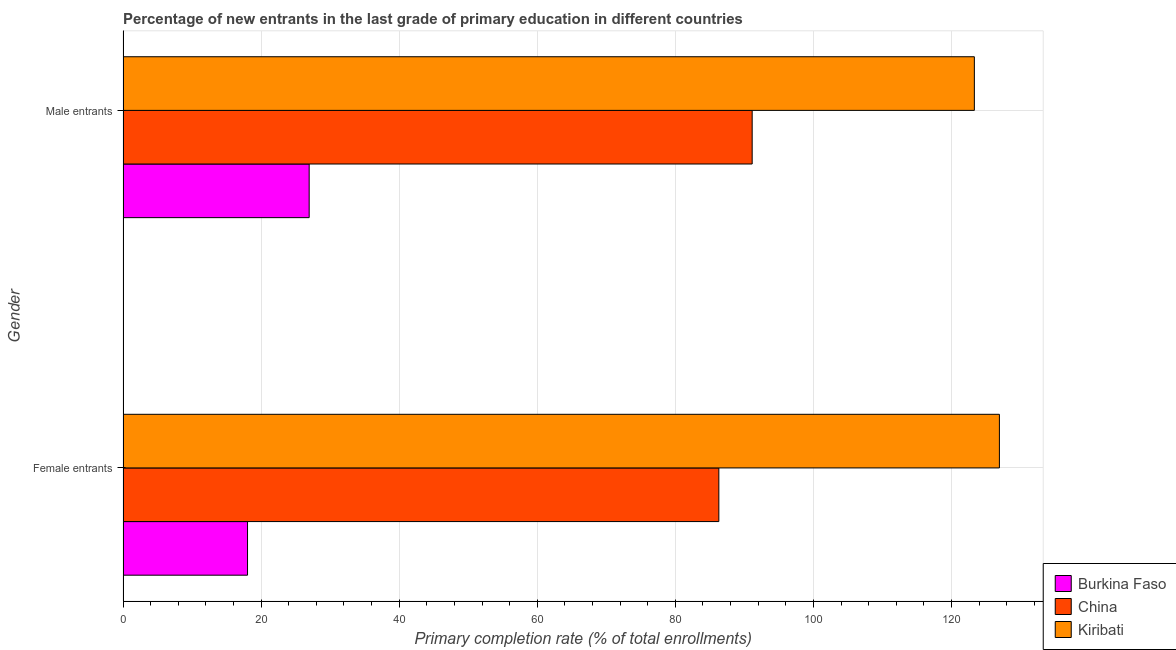Are the number of bars on each tick of the Y-axis equal?
Provide a succinct answer. Yes. How many bars are there on the 1st tick from the top?
Provide a succinct answer. 3. What is the label of the 2nd group of bars from the top?
Provide a short and direct response. Female entrants. What is the primary completion rate of male entrants in Burkina Faso?
Offer a terse response. 26.97. Across all countries, what is the maximum primary completion rate of female entrants?
Offer a terse response. 126.94. Across all countries, what is the minimum primary completion rate of female entrants?
Keep it short and to the point. 18.04. In which country was the primary completion rate of female entrants maximum?
Your response must be concise. Kiribati. In which country was the primary completion rate of female entrants minimum?
Provide a short and direct response. Burkina Faso. What is the total primary completion rate of male entrants in the graph?
Your answer should be very brief. 241.41. What is the difference between the primary completion rate of male entrants in Kiribati and that in Burkina Faso?
Give a very brief answer. 96.35. What is the difference between the primary completion rate of male entrants in Burkina Faso and the primary completion rate of female entrants in Kiribati?
Keep it short and to the point. -99.97. What is the average primary completion rate of male entrants per country?
Your answer should be compact. 80.47. What is the difference between the primary completion rate of female entrants and primary completion rate of male entrants in Kiribati?
Provide a succinct answer. 3.63. What is the ratio of the primary completion rate of male entrants in China to that in Kiribati?
Your response must be concise. 0.74. Is the primary completion rate of female entrants in China less than that in Kiribati?
Provide a short and direct response. Yes. In how many countries, is the primary completion rate of female entrants greater than the average primary completion rate of female entrants taken over all countries?
Your answer should be compact. 2. What does the 2nd bar from the top in Male entrants represents?
Give a very brief answer. China. What does the 1st bar from the bottom in Female entrants represents?
Make the answer very short. Burkina Faso. Are the values on the major ticks of X-axis written in scientific E-notation?
Offer a very short reply. No. Where does the legend appear in the graph?
Provide a short and direct response. Bottom right. How are the legend labels stacked?
Your answer should be very brief. Vertical. What is the title of the graph?
Your response must be concise. Percentage of new entrants in the last grade of primary education in different countries. Does "Seychelles" appear as one of the legend labels in the graph?
Provide a short and direct response. No. What is the label or title of the X-axis?
Provide a short and direct response. Primary completion rate (% of total enrollments). What is the label or title of the Y-axis?
Ensure brevity in your answer.  Gender. What is the Primary completion rate (% of total enrollments) in Burkina Faso in Female entrants?
Your answer should be compact. 18.04. What is the Primary completion rate (% of total enrollments) in China in Female entrants?
Offer a terse response. 86.3. What is the Primary completion rate (% of total enrollments) in Kiribati in Female entrants?
Provide a short and direct response. 126.94. What is the Primary completion rate (% of total enrollments) of Burkina Faso in Male entrants?
Your answer should be compact. 26.97. What is the Primary completion rate (% of total enrollments) of China in Male entrants?
Provide a succinct answer. 91.13. What is the Primary completion rate (% of total enrollments) of Kiribati in Male entrants?
Give a very brief answer. 123.31. Across all Gender, what is the maximum Primary completion rate (% of total enrollments) of Burkina Faso?
Your answer should be very brief. 26.97. Across all Gender, what is the maximum Primary completion rate (% of total enrollments) of China?
Your answer should be very brief. 91.13. Across all Gender, what is the maximum Primary completion rate (% of total enrollments) in Kiribati?
Offer a terse response. 126.94. Across all Gender, what is the minimum Primary completion rate (% of total enrollments) in Burkina Faso?
Provide a short and direct response. 18.04. Across all Gender, what is the minimum Primary completion rate (% of total enrollments) of China?
Ensure brevity in your answer.  86.3. Across all Gender, what is the minimum Primary completion rate (% of total enrollments) in Kiribati?
Make the answer very short. 123.31. What is the total Primary completion rate (% of total enrollments) in Burkina Faso in the graph?
Provide a short and direct response. 45. What is the total Primary completion rate (% of total enrollments) of China in the graph?
Give a very brief answer. 177.43. What is the total Primary completion rate (% of total enrollments) in Kiribati in the graph?
Offer a terse response. 250.25. What is the difference between the Primary completion rate (% of total enrollments) of Burkina Faso in Female entrants and that in Male entrants?
Provide a short and direct response. -8.93. What is the difference between the Primary completion rate (% of total enrollments) in China in Female entrants and that in Male entrants?
Your answer should be very brief. -4.83. What is the difference between the Primary completion rate (% of total enrollments) of Kiribati in Female entrants and that in Male entrants?
Ensure brevity in your answer.  3.63. What is the difference between the Primary completion rate (% of total enrollments) of Burkina Faso in Female entrants and the Primary completion rate (% of total enrollments) of China in Male entrants?
Offer a very short reply. -73.09. What is the difference between the Primary completion rate (% of total enrollments) in Burkina Faso in Female entrants and the Primary completion rate (% of total enrollments) in Kiribati in Male entrants?
Make the answer very short. -105.27. What is the difference between the Primary completion rate (% of total enrollments) of China in Female entrants and the Primary completion rate (% of total enrollments) of Kiribati in Male entrants?
Provide a short and direct response. -37.01. What is the average Primary completion rate (% of total enrollments) in Burkina Faso per Gender?
Offer a very short reply. 22.5. What is the average Primary completion rate (% of total enrollments) of China per Gender?
Your answer should be compact. 88.72. What is the average Primary completion rate (% of total enrollments) of Kiribati per Gender?
Offer a terse response. 125.13. What is the difference between the Primary completion rate (% of total enrollments) of Burkina Faso and Primary completion rate (% of total enrollments) of China in Female entrants?
Ensure brevity in your answer.  -68.27. What is the difference between the Primary completion rate (% of total enrollments) of Burkina Faso and Primary completion rate (% of total enrollments) of Kiribati in Female entrants?
Keep it short and to the point. -108.9. What is the difference between the Primary completion rate (% of total enrollments) in China and Primary completion rate (% of total enrollments) in Kiribati in Female entrants?
Your answer should be compact. -40.64. What is the difference between the Primary completion rate (% of total enrollments) in Burkina Faso and Primary completion rate (% of total enrollments) in China in Male entrants?
Your response must be concise. -64.17. What is the difference between the Primary completion rate (% of total enrollments) in Burkina Faso and Primary completion rate (% of total enrollments) in Kiribati in Male entrants?
Provide a succinct answer. -96.35. What is the difference between the Primary completion rate (% of total enrollments) of China and Primary completion rate (% of total enrollments) of Kiribati in Male entrants?
Your answer should be compact. -32.18. What is the ratio of the Primary completion rate (% of total enrollments) of Burkina Faso in Female entrants to that in Male entrants?
Ensure brevity in your answer.  0.67. What is the ratio of the Primary completion rate (% of total enrollments) in China in Female entrants to that in Male entrants?
Offer a terse response. 0.95. What is the ratio of the Primary completion rate (% of total enrollments) in Kiribati in Female entrants to that in Male entrants?
Provide a short and direct response. 1.03. What is the difference between the highest and the second highest Primary completion rate (% of total enrollments) of Burkina Faso?
Ensure brevity in your answer.  8.93. What is the difference between the highest and the second highest Primary completion rate (% of total enrollments) in China?
Give a very brief answer. 4.83. What is the difference between the highest and the second highest Primary completion rate (% of total enrollments) of Kiribati?
Give a very brief answer. 3.63. What is the difference between the highest and the lowest Primary completion rate (% of total enrollments) of Burkina Faso?
Offer a terse response. 8.93. What is the difference between the highest and the lowest Primary completion rate (% of total enrollments) of China?
Provide a short and direct response. 4.83. What is the difference between the highest and the lowest Primary completion rate (% of total enrollments) of Kiribati?
Make the answer very short. 3.63. 